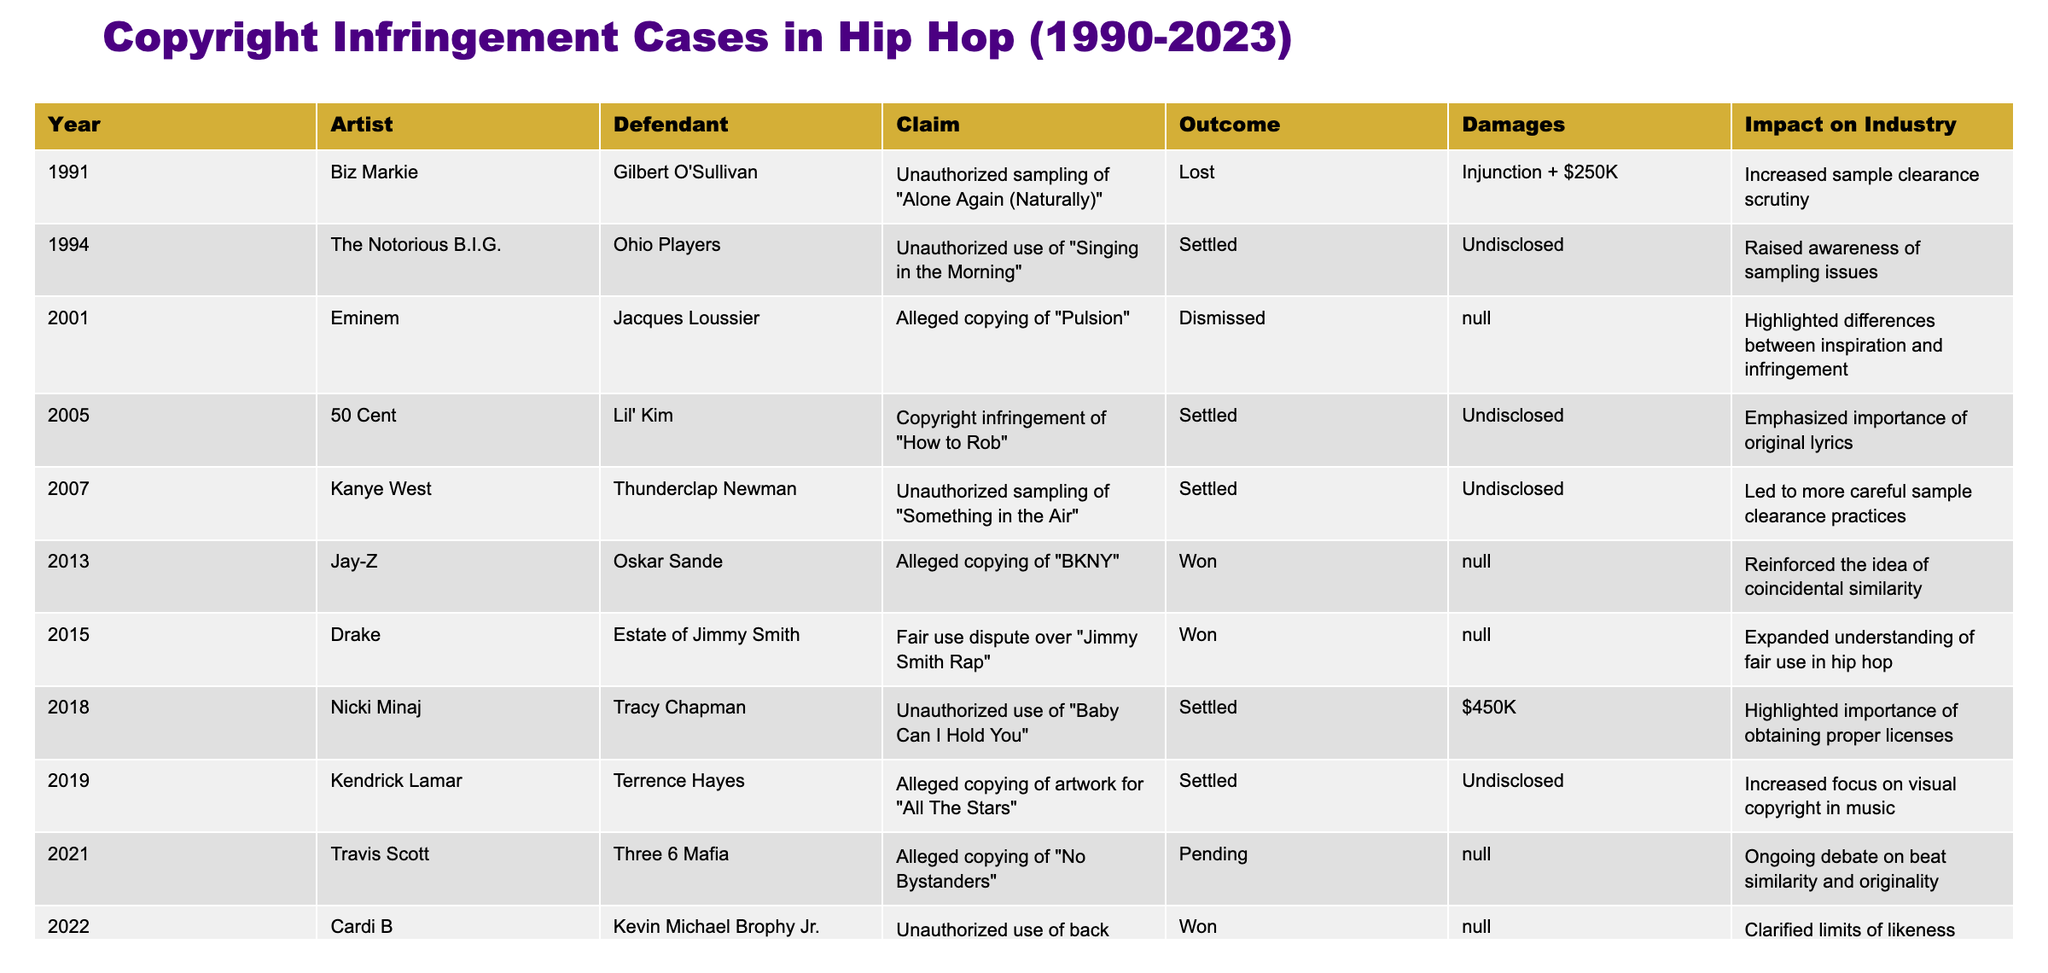What year did Biz Markie face a copyright infringement case? The table lists 1991 as the year when Biz Markie was involved in a copyright infringement case involving Gilbert O'Sullivan.
Answer: 1991 What was the claim in the case involving Nicki Minaj? According to the table, Nicki Minaj was involved in a case concerning the unauthorized use of Tracy Chapman's "Baby Can I Hold You."
Answer: Unauthorized use of "Baby Can I Hold You" How many cases resulted in a win for the artist? The table shows two cases where the artist won: Jay-Z in 2013 and Cardi B in 2022, making a total of two wins.
Answer: 2 Which artist had a case with a pending outcome in 2021? The table indicates that Travis Scott is the artist with a pending outcome in 2021 regarding the case with Three 6 Mafia.
Answer: Travis Scott What is the total number of cases that settled out of court from the data provided? Counting the entries, there are six cases marked as settled: The Notorious B.I.G., 50 Cent, Kanye West, Nicki Minaj, Kendrick Lamar, and Travis Scott.
Answer: 6 Which claim involved the highest amount of damages? The only case with a specified damages amount is Nicki Minaj's, with $450K, which is the highest listed in the table.
Answer: $450K Has any artist's case highlighted issues related to visual copyright in music? Yes, the case involving Kendrick Lamar in 2019 increased the focus on visual copyright in music.
Answer: Yes What are the outcomes for cases against artists that occurred after 2015? From 2015 onward, there were three cases: one won (Cardi B) and two pending outcomes (Travis Scott and Megan Thee Stallion).
Answer: 1 won, 2 pending Which artist's case emphasized the importance of obtaining proper licenses? The case involving Nicki Minaj emphasized the importance of obtaining proper licenses for the unauthorized use of a song.
Answer: Nicki Minaj What was the primary impact of cases involving unauthorized sampling? The cases listed primarily led to increased scrutiny and awareness regarding sample clearance practices among hip hop artists.
Answer: Increased scrutiny on sample clearance 